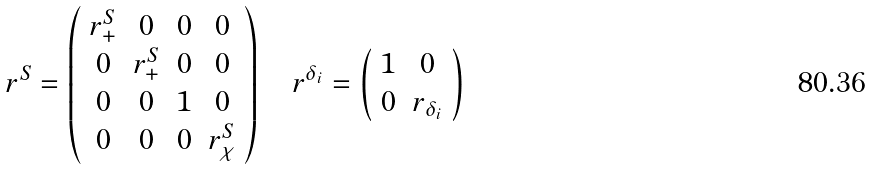<formula> <loc_0><loc_0><loc_500><loc_500>r ^ { S } = \left ( \begin{array} { c c c c } { { r _ { + } ^ { S } } } & { 0 } & { 0 } & { 0 } \\ { 0 } & { { r _ { + } ^ { S } } } & { 0 } & { 0 } \\ { 0 } & { 0 } & { 1 } & { 0 } \\ { 0 } & { 0 } & { 0 } & { { r _ { \chi } ^ { S } } } \end{array} \right ) \quad r ^ { \delta _ { i } } = \left ( \begin{array} { c c } { 1 } & { 0 } \\ { 0 } & { { r _ { \delta _ { i } } } } \end{array} \right )</formula> 